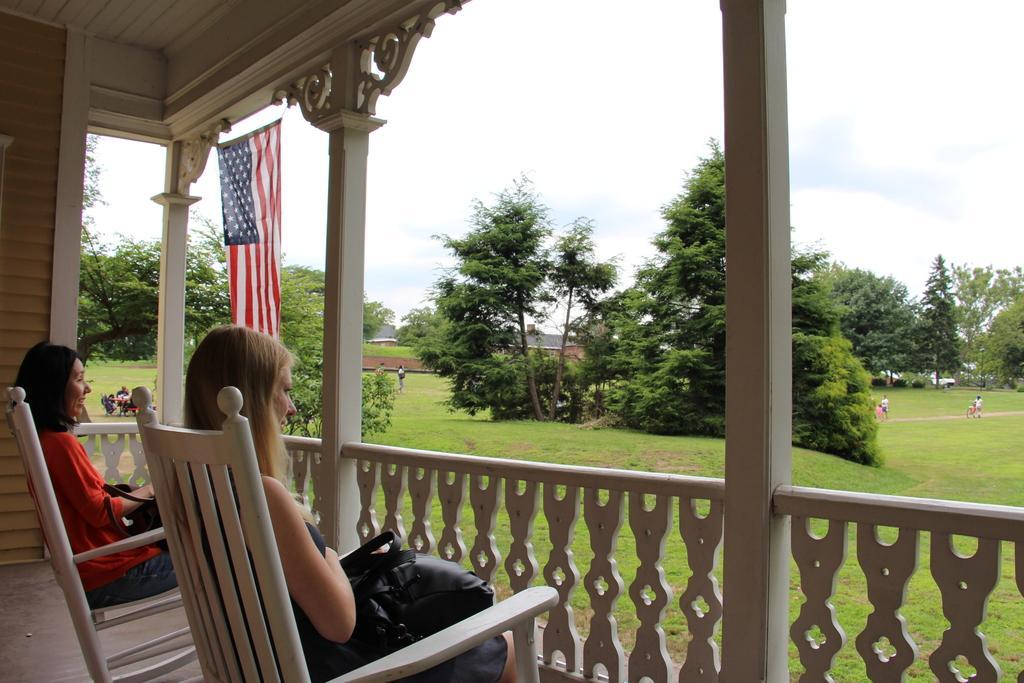Could you give a brief overview of what you see in this image? In this picture we can see two persons are sitting on the chairs. This is grass and there are trees. Here we can see a flag. On the background there is a sky. 